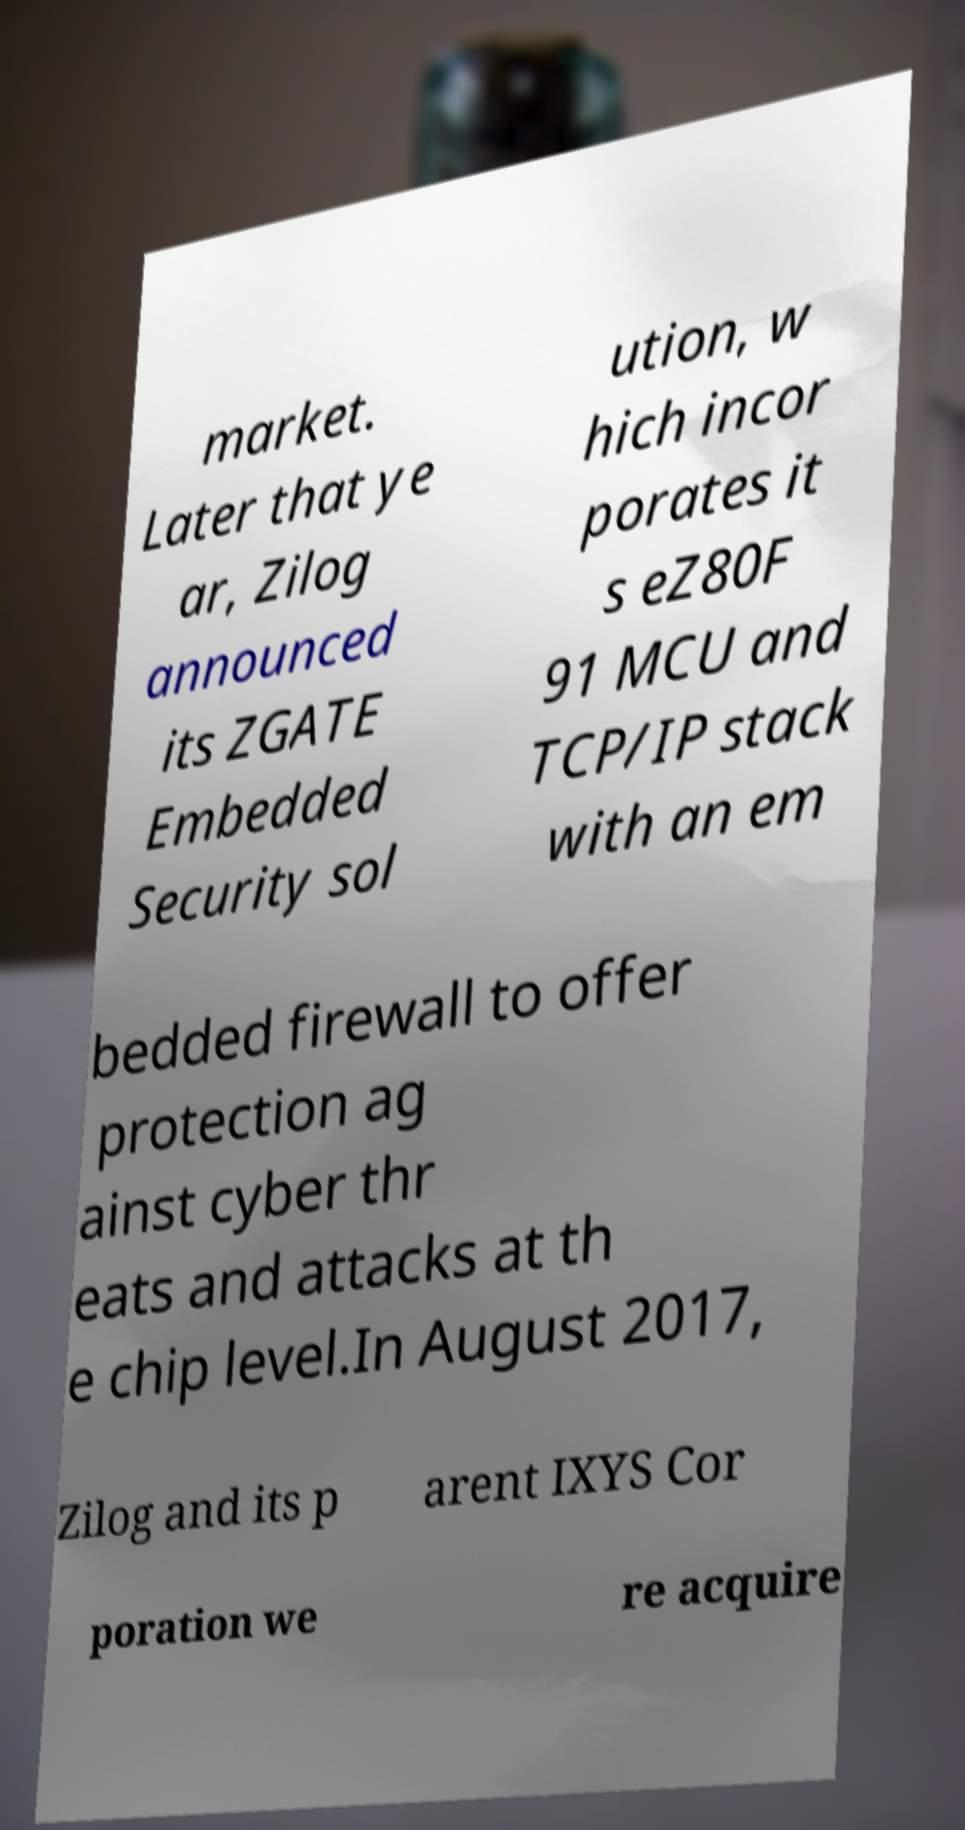Can you read and provide the text displayed in the image?This photo seems to have some interesting text. Can you extract and type it out for me? market. Later that ye ar, Zilog announced its ZGATE Embedded Security sol ution, w hich incor porates it s eZ80F 91 MCU and TCP/IP stack with an em bedded firewall to offer protection ag ainst cyber thr eats and attacks at th e chip level.In August 2017, Zilog and its p arent IXYS Cor poration we re acquire 